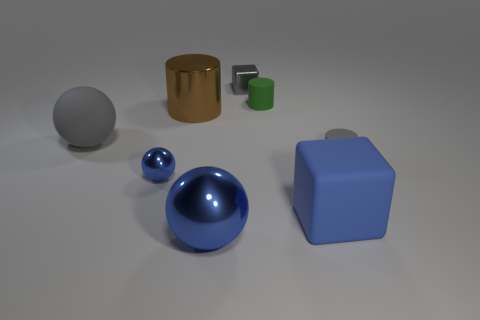How many tiny objects are either rubber cylinders or brown shiny cylinders? In the image, there are two objects that fit the description of being small, cylindrical, and one is rubber while the other is a shiny brown. Thus, a total of 2 cylinders meet the criteria. 